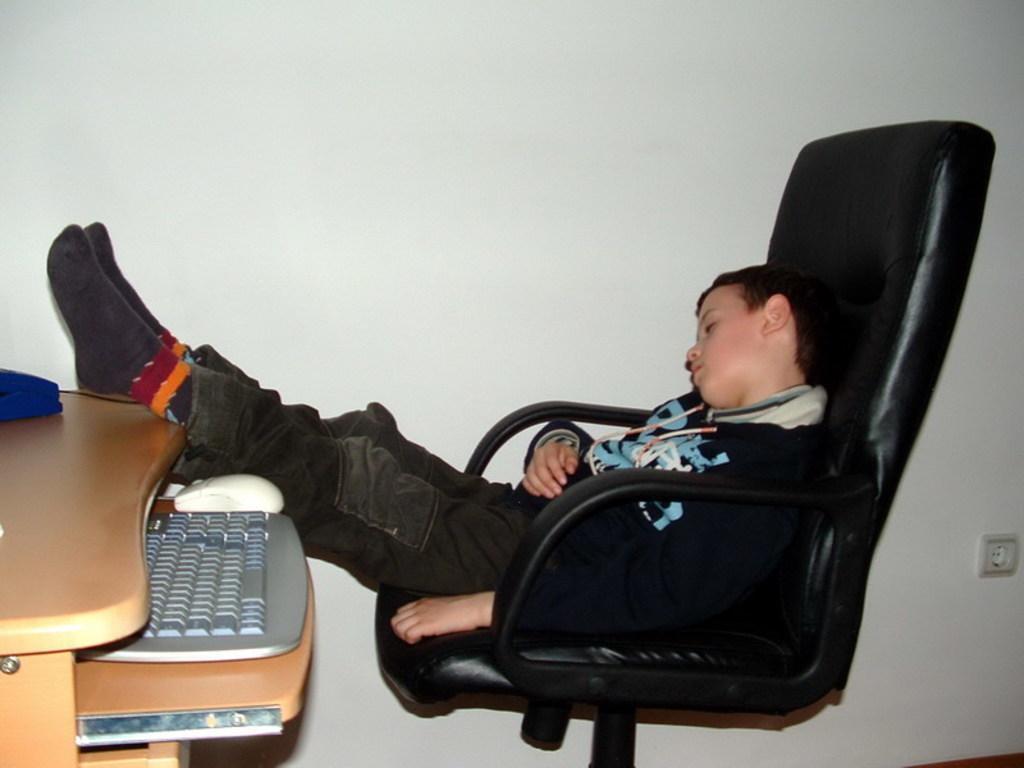Please provide a concise description of this image. The image is taken inside a room. In the center of the image there is a chair. There is a boy sitting on a chair. On the left there is table. There is a keyboard and a mouse placed on a table. In the background there is a wall. 